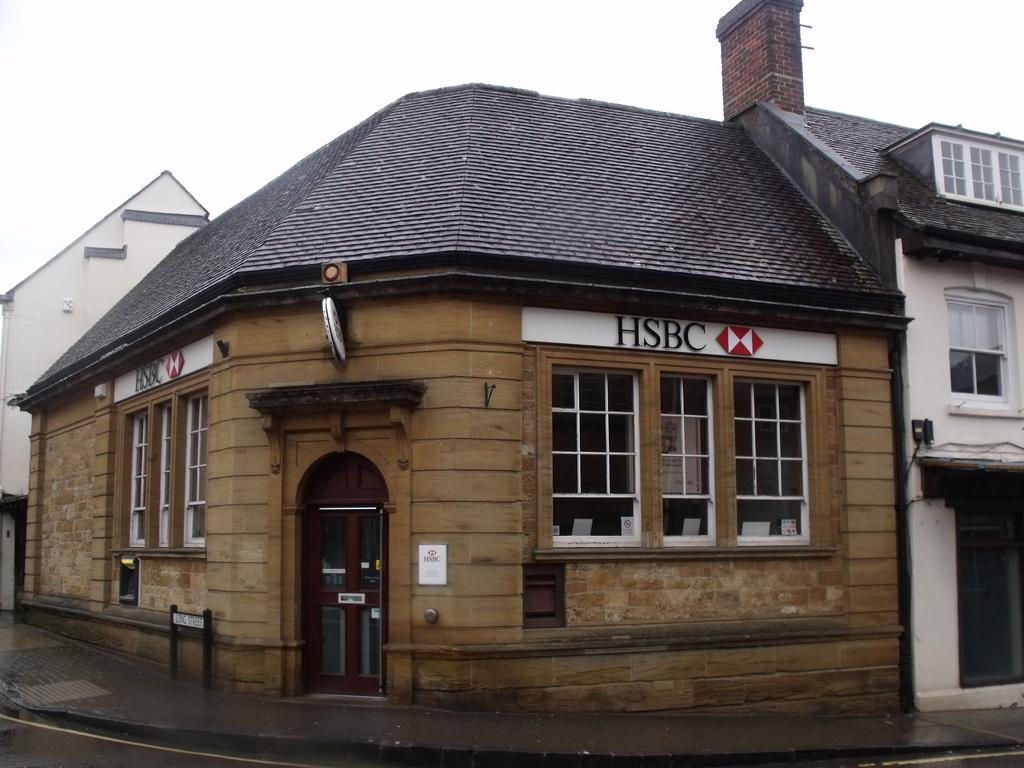What type of structure is present in the image? There is a building in the image. What feature can be observed on the building? The building has glass windows. What colors are used in the building's design? The building is in brown, black, and white colors. Is there an entrance to the building visible in the image? Yes, there is a door in the building. What is the color of the sky in the image? The sky is white in color. How many girls are sitting on the channel in the image? There is no channel or girls present in the image; it features a building with a door and glass windows. 